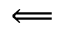<formula> <loc_0><loc_0><loc_500><loc_500>\Longleftarrow</formula> 